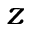Convert formula to latex. <formula><loc_0><loc_0><loc_500><loc_500>z</formula> 